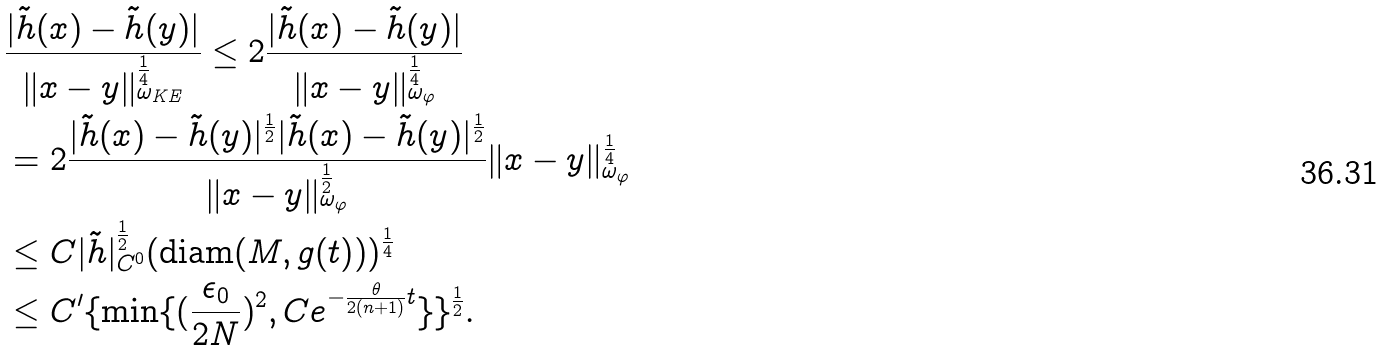<formula> <loc_0><loc_0><loc_500><loc_500>& \frac { | \tilde { h } ( x ) - \tilde { h } ( y ) | } { \| x - y \| ^ { \frac { 1 } { 4 } } _ { \omega _ { K E } } } \leq 2 \frac { | \tilde { h } ( x ) - \tilde { h } ( y ) | } { \| x - y \| ^ { \frac { 1 } { 4 } } _ { \omega _ { \varphi } } } \\ & = 2 \frac { | \tilde { h } ( x ) - \tilde { h } ( y ) | ^ { \frac { 1 } { 2 } } | \tilde { h } ( x ) - \tilde { h } ( y ) | ^ { \frac { 1 } { 2 } } } { \| x - y \| ^ { \frac { 1 } { 2 } } _ { \omega _ { \varphi } } } \| x - y \| ^ { \frac { 1 } { 4 } } _ { \omega _ { \varphi } } \\ & \leq C | \tilde { h } | ^ { \frac { 1 } { 2 } } _ { C ^ { 0 } } ( \text {diam} ( M , g ( t ) ) ) ^ { \frac { 1 } { 4 } } \\ & \leq C ^ { \prime } \{ \min \{ ( \frac { \epsilon _ { 0 } } { 2 N } ) ^ { 2 } , C e ^ { - \frac { \theta } { 2 ( n + 1 ) } t } \} \} ^ { \frac { 1 } { 2 } } .</formula> 